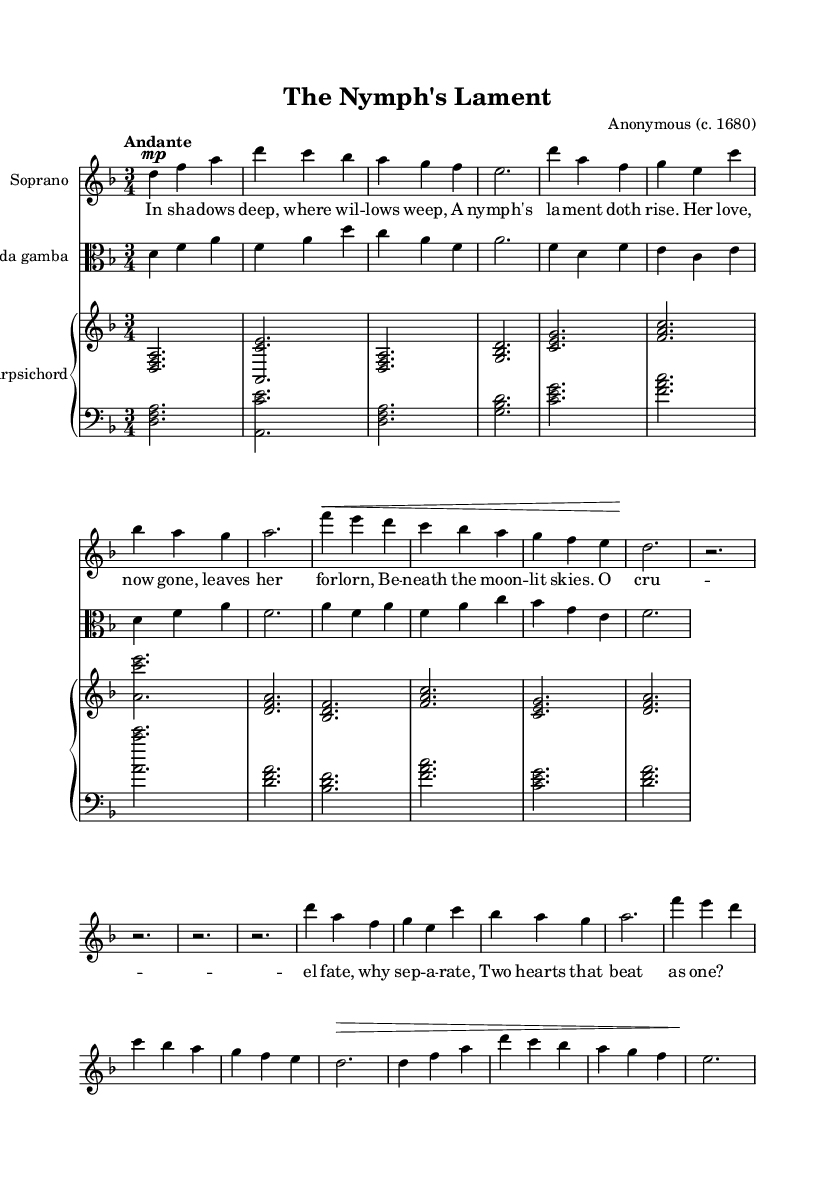What is the key signature of this music? The key signature shows two flats (B♭ and E♭), indicating it's in D minor.
Answer: D minor What is the time signature of this music? The time signature is displayed at the beginning of the score, showing three beats per measure.
Answer: 3/4 What is the tempo marking of the piece? The tempo marking is written above the staff and indicates a moderate speed with the term "Andante".
Answer: Andante How many verses are indicated in the lyrics? The lyrics contain two sections labeled as verses, specifically "Verse 1" and "Verse 2".
Answer: 2 What instrument is featured as the main melodic voice? The soprano part is explicitly mentioned at the top of the first staff as the main melodic voice for this piece.
Answer: Soprano What type of musical composition is "The Nymph's Lament"? The combination of music, dance, and theater in this work categorizes it as a Baroque masque, often featuring elaborate performances.
Answer: Baroque masque What is the role of the viola in this piece? The viola part complements the soprano melody by providing harmonic support and texture typical in Baroque chamber music.
Answer: Harmonic support 